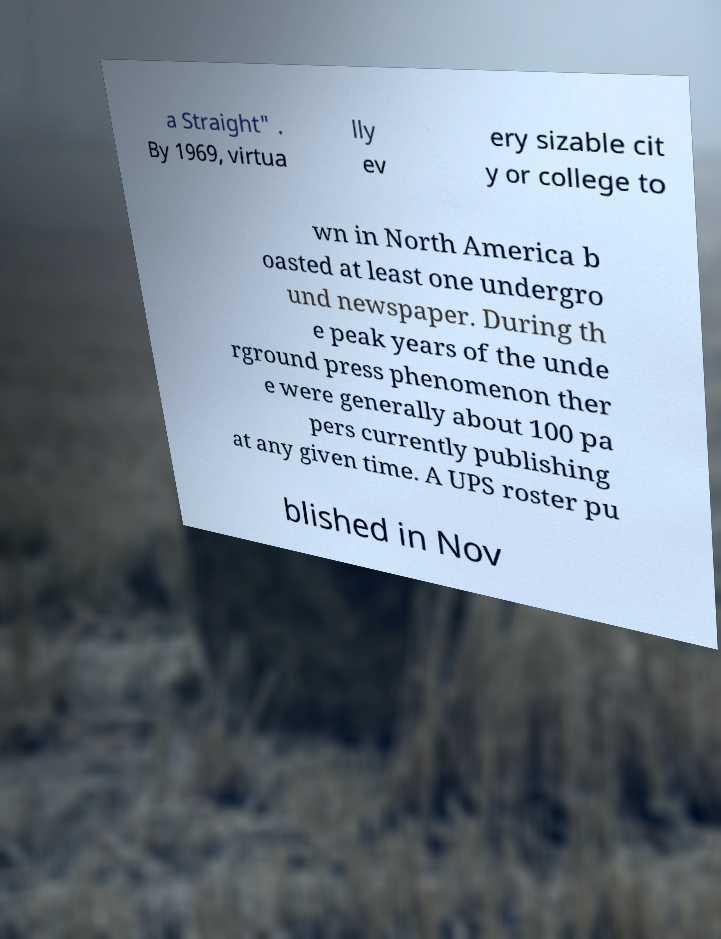Please read and relay the text visible in this image. What does it say? a Straight" . By 1969, virtua lly ev ery sizable cit y or college to wn in North America b oasted at least one undergro und newspaper. During th e peak years of the unde rground press phenomenon ther e were generally about 100 pa pers currently publishing at any given time. A UPS roster pu blished in Nov 